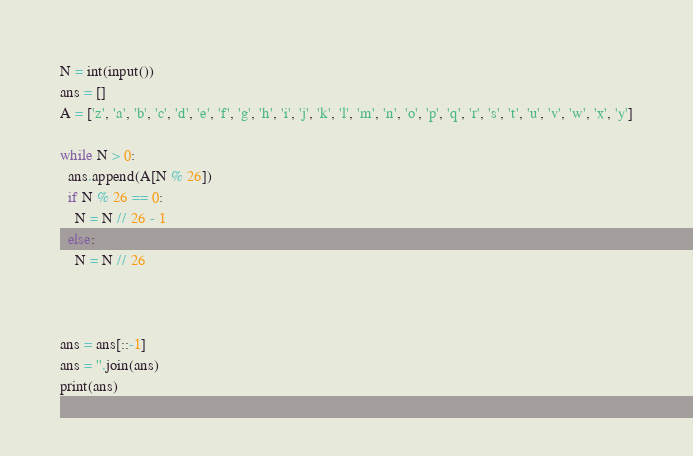Convert code to text. <code><loc_0><loc_0><loc_500><loc_500><_Python_>N = int(input())
ans = []
A = ['z', 'a', 'b', 'c', 'd', 'e', 'f', 'g', 'h', 'i', 'j', 'k', 'l', 'm', 'n', 'o', 'p', 'q', 'r', 's', 't', 'u', 'v', 'w', 'x', 'y']

while N > 0:
  ans.append(A[N % 26])
  if N % 26 == 0:
    N = N // 26 - 1
  else:
    N = N // 26

  

ans = ans[::-1]
ans = ''.join(ans)
print(ans)</code> 